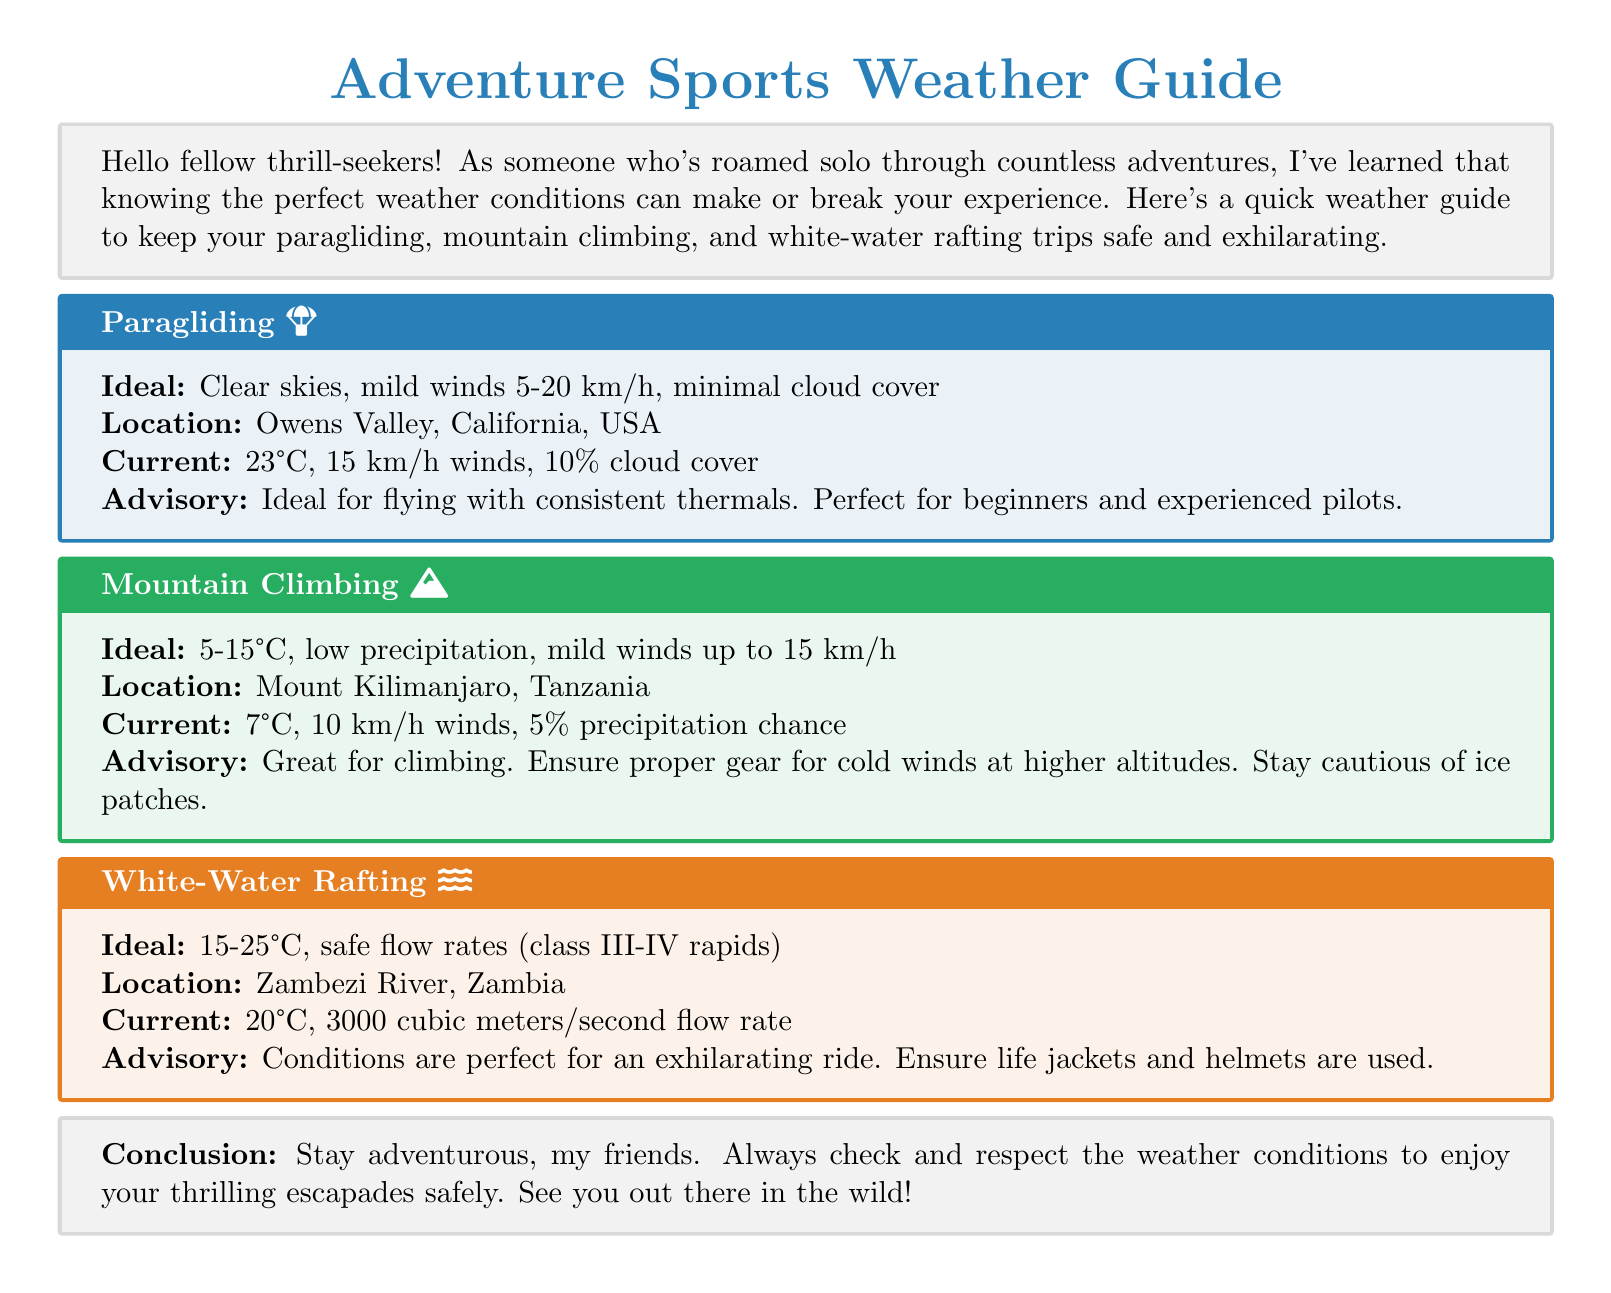What is the ideal wind speed for paragliding? The ideal wind speed for paragliding is between 5-20 km/h.
Answer: 5-20 km/h Where is the current location for mountain climbing? The current location for mountain climbing is Mount Kilimanjaro, Tanzania.
Answer: Mount Kilimanjaro, Tanzania What is the current temperature for white-water rafting? The current temperature for white-water rafting is 20°C.
Answer: 20°C What is the precipitation chance for mountain climbing? The precipitation chance for mountain climbing is 5%.
Answer: 5% What advisory is given for paragliding? The advisory for paragliding is that it's ideal for flying with consistent thermals.
Answer: Ideal for flying with consistent thermals What conditions are described for an exhilarating white-water rafting ride? The conditions for an exhilarating white-water rafting ride are perfect.
Answer: Perfect What is the ideal temperature range for mountain climbing? The ideal temperature range for mountain climbing is 5-15°C.
Answer: 5-15°C What is the flow rate for the Zambezi River? The flow rate for the Zambezi River is 3000 cubic meters/second.
Answer: 3000 cubic meters/second What should users ensure while white-water rafting? Users should ensure life jackets and helmets are used.
Answer: Life jackets and helmets 